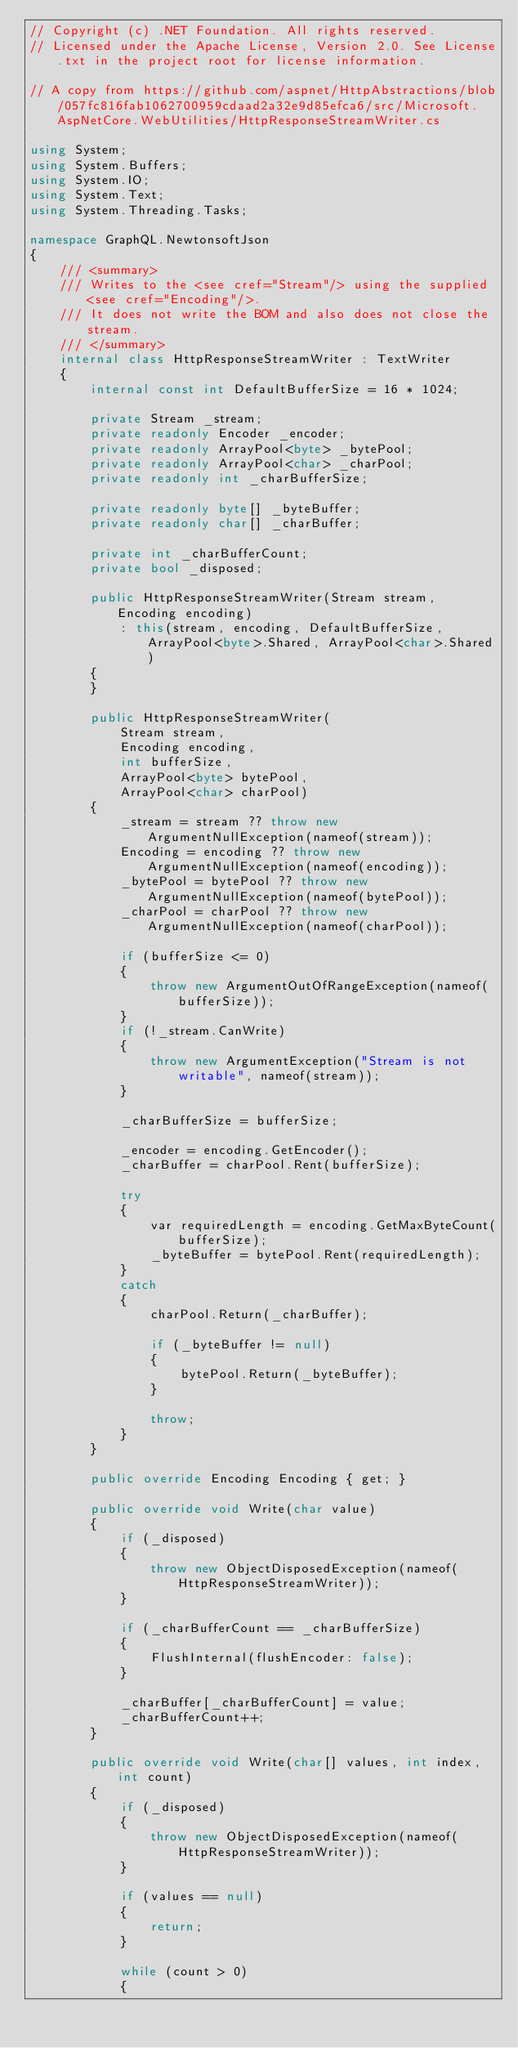<code> <loc_0><loc_0><loc_500><loc_500><_C#_>// Copyright (c) .NET Foundation. All rights reserved.
// Licensed under the Apache License, Version 2.0. See License.txt in the project root for license information.

// A copy from https://github.com/aspnet/HttpAbstractions/blob/057fc816fab1062700959cdaad2a32e9d85efca6/src/Microsoft.AspNetCore.WebUtilities/HttpResponseStreamWriter.cs

using System;
using System.Buffers;
using System.IO;
using System.Text;
using System.Threading.Tasks;

namespace GraphQL.NewtonsoftJson
{
    /// <summary>
    /// Writes to the <see cref="Stream"/> using the supplied <see cref="Encoding"/>.
    /// It does not write the BOM and also does not close the stream.
    /// </summary>
    internal class HttpResponseStreamWriter : TextWriter
    {
        internal const int DefaultBufferSize = 16 * 1024;

        private Stream _stream;
        private readonly Encoder _encoder;
        private readonly ArrayPool<byte> _bytePool;
        private readonly ArrayPool<char> _charPool;
        private readonly int _charBufferSize;

        private readonly byte[] _byteBuffer;
        private readonly char[] _charBuffer;

        private int _charBufferCount;
        private bool _disposed;

        public HttpResponseStreamWriter(Stream stream, Encoding encoding)
            : this(stream, encoding, DefaultBufferSize, ArrayPool<byte>.Shared, ArrayPool<char>.Shared)
        {
        }

        public HttpResponseStreamWriter(
            Stream stream,
            Encoding encoding,
            int bufferSize,
            ArrayPool<byte> bytePool,
            ArrayPool<char> charPool)
        {
            _stream = stream ?? throw new ArgumentNullException(nameof(stream));
            Encoding = encoding ?? throw new ArgumentNullException(nameof(encoding));
            _bytePool = bytePool ?? throw new ArgumentNullException(nameof(bytePool));
            _charPool = charPool ?? throw new ArgumentNullException(nameof(charPool));

            if (bufferSize <= 0)
            {
                throw new ArgumentOutOfRangeException(nameof(bufferSize));
            }
            if (!_stream.CanWrite)
            {
                throw new ArgumentException("Stream is not writable", nameof(stream));
            }

            _charBufferSize = bufferSize;

            _encoder = encoding.GetEncoder();
            _charBuffer = charPool.Rent(bufferSize);

            try
            {
                var requiredLength = encoding.GetMaxByteCount(bufferSize);
                _byteBuffer = bytePool.Rent(requiredLength);
            }
            catch
            {
                charPool.Return(_charBuffer);

                if (_byteBuffer != null)
                {
                    bytePool.Return(_byteBuffer);
                }

                throw;
            }
        }

        public override Encoding Encoding { get; }

        public override void Write(char value)
        {
            if (_disposed)
            {
                throw new ObjectDisposedException(nameof(HttpResponseStreamWriter));
            }

            if (_charBufferCount == _charBufferSize)
            {
                FlushInternal(flushEncoder: false);
            }

            _charBuffer[_charBufferCount] = value;
            _charBufferCount++;
        }

        public override void Write(char[] values, int index, int count)
        {
            if (_disposed)
            {
                throw new ObjectDisposedException(nameof(HttpResponseStreamWriter));
            }

            if (values == null)
            {
                return;
            }

            while (count > 0)
            {</code> 